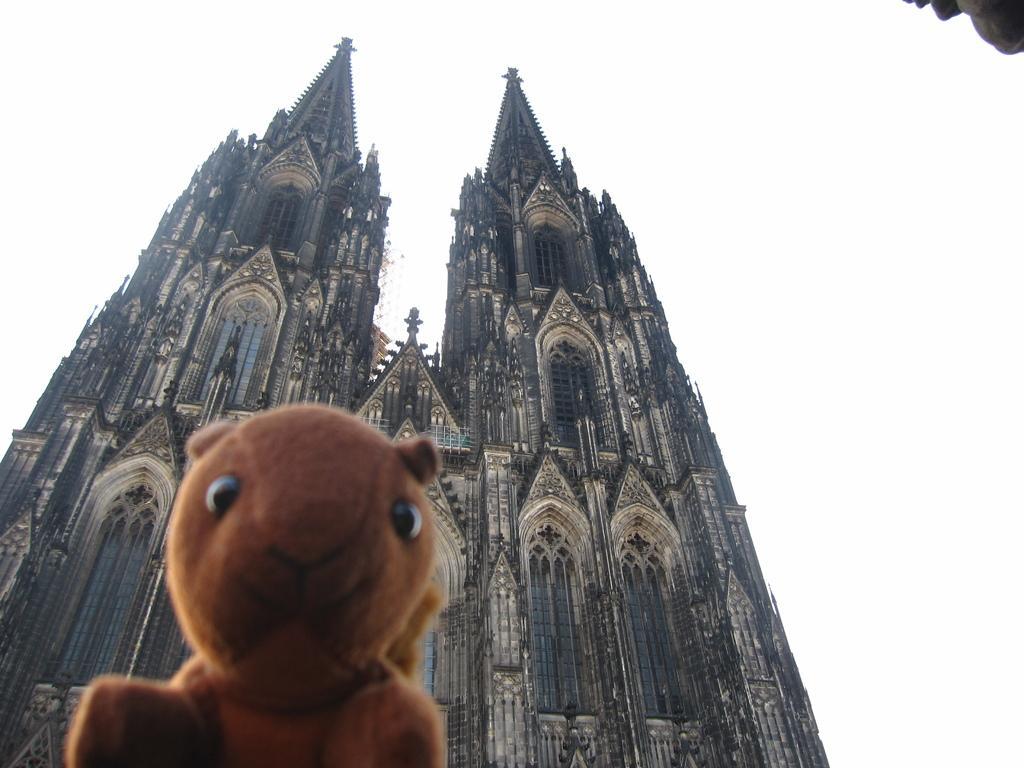How would you summarize this image in a sentence or two? There is a soft toy. At the back there are buildings. 